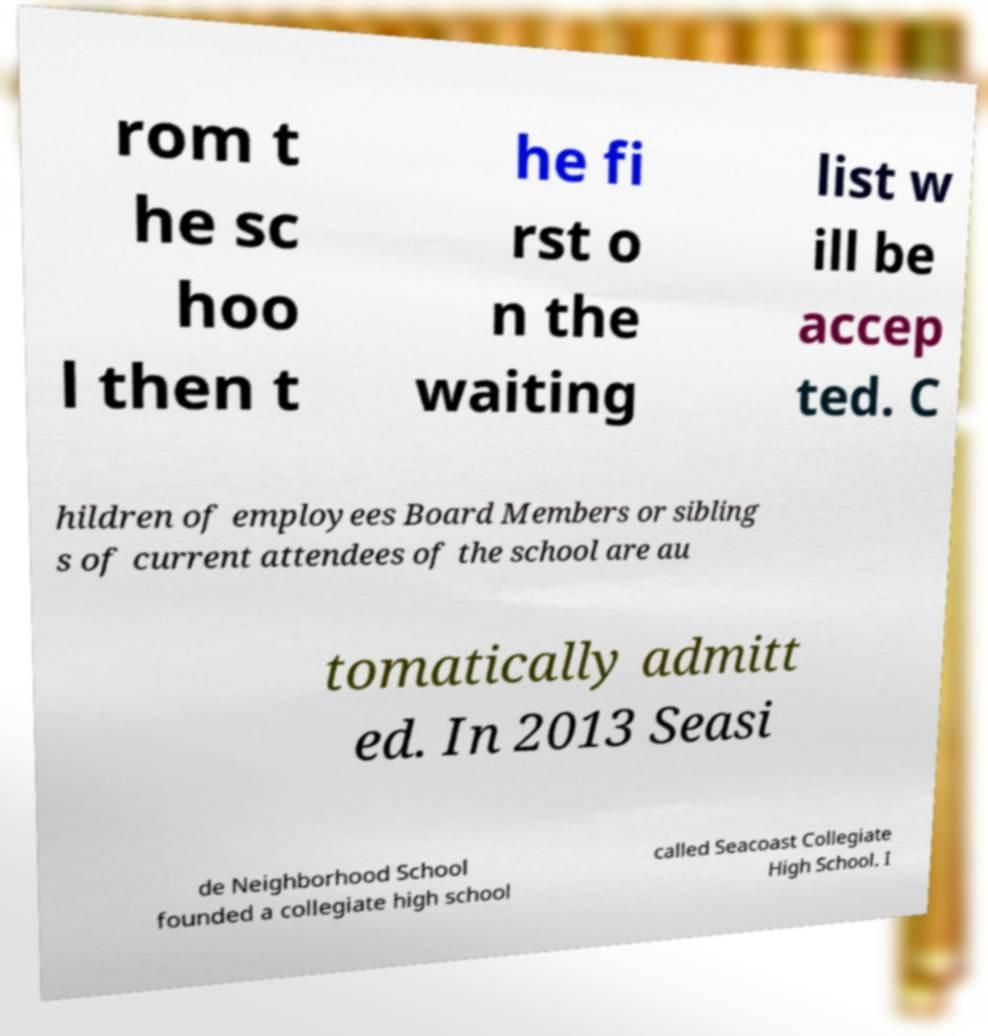Please identify and transcribe the text found in this image. rom t he sc hoo l then t he fi rst o n the waiting list w ill be accep ted. C hildren of employees Board Members or sibling s of current attendees of the school are au tomatically admitt ed. In 2013 Seasi de Neighborhood School founded a collegiate high school called Seacoast Collegiate High School. I 